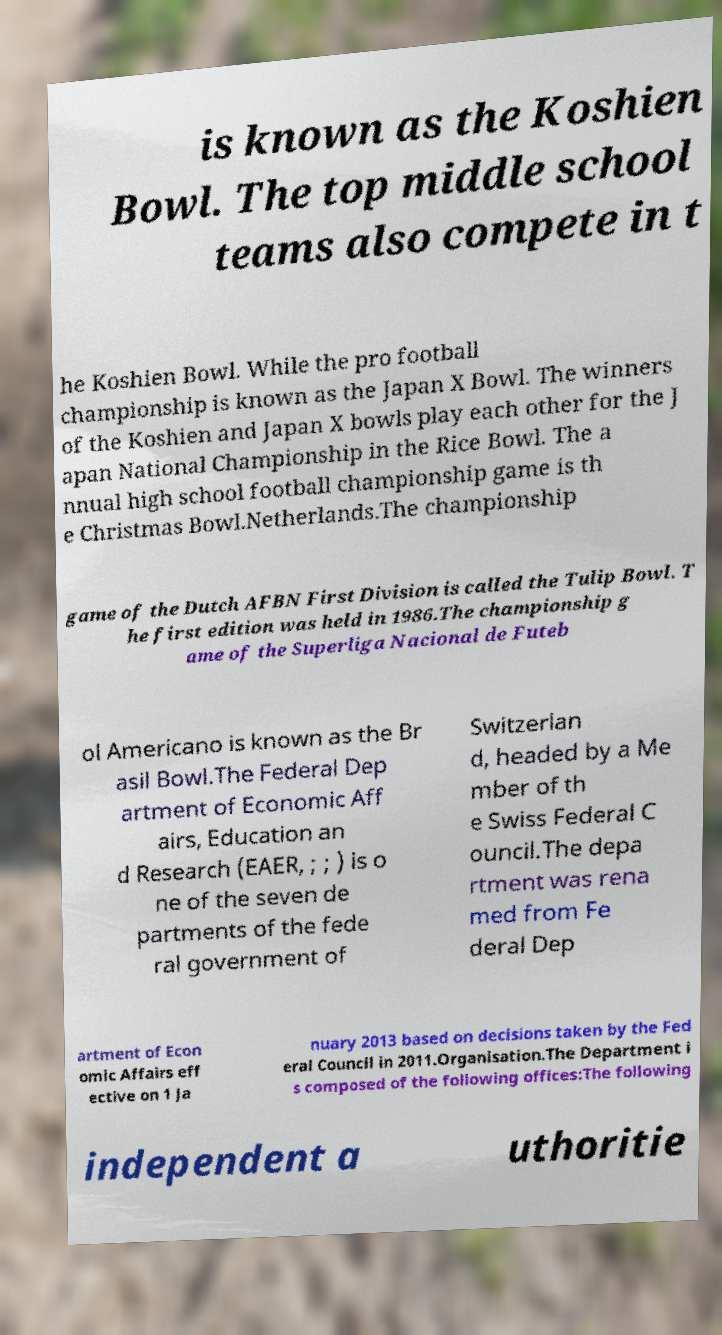Can you accurately transcribe the text from the provided image for me? is known as the Koshien Bowl. The top middle school teams also compete in t he Koshien Bowl. While the pro football championship is known as the Japan X Bowl. The winners of the Koshien and Japan X bowls play each other for the J apan National Championship in the Rice Bowl. The a nnual high school football championship game is th e Christmas Bowl.Netherlands.The championship game of the Dutch AFBN First Division is called the Tulip Bowl. T he first edition was held in 1986.The championship g ame of the Superliga Nacional de Futeb ol Americano is known as the Br asil Bowl.The Federal Dep artment of Economic Aff airs, Education an d Research (EAER, ; ; ) is o ne of the seven de partments of the fede ral government of Switzerlan d, headed by a Me mber of th e Swiss Federal C ouncil.The depa rtment was rena med from Fe deral Dep artment of Econ omic Affairs eff ective on 1 Ja nuary 2013 based on decisions taken by the Fed eral Council in 2011.Organisation.The Department i s composed of the following offices:The following independent a uthoritie 